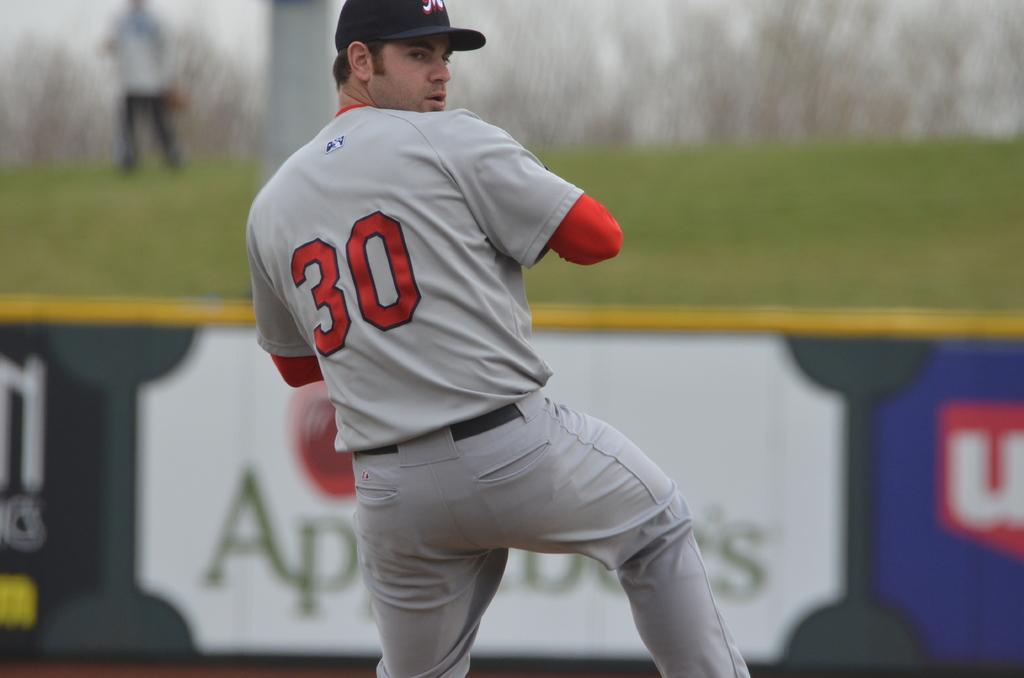What is the number of the pitcher?
Your answer should be compact. 30. What is the first letter of the sign on the far right?
Make the answer very short. U. 